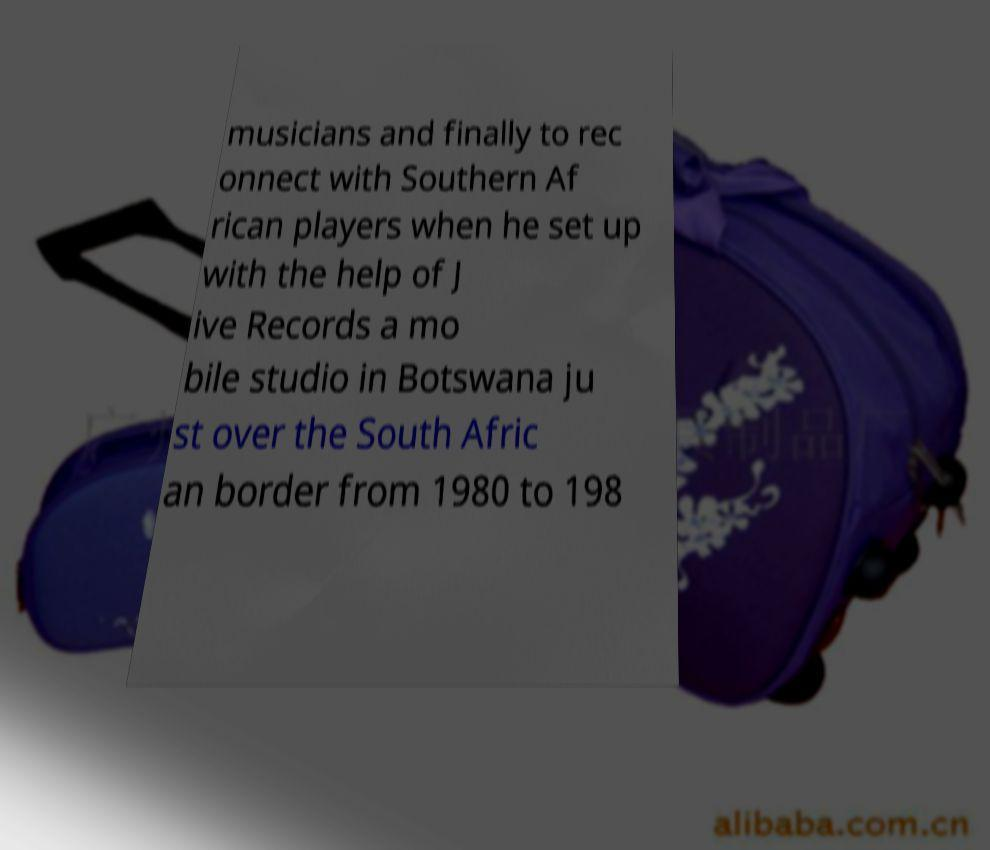Could you extract and type out the text from this image? musicians and finally to rec onnect with Southern Af rican players when he set up with the help of J ive Records a mo bile studio in Botswana ju st over the South Afric an border from 1980 to 198 